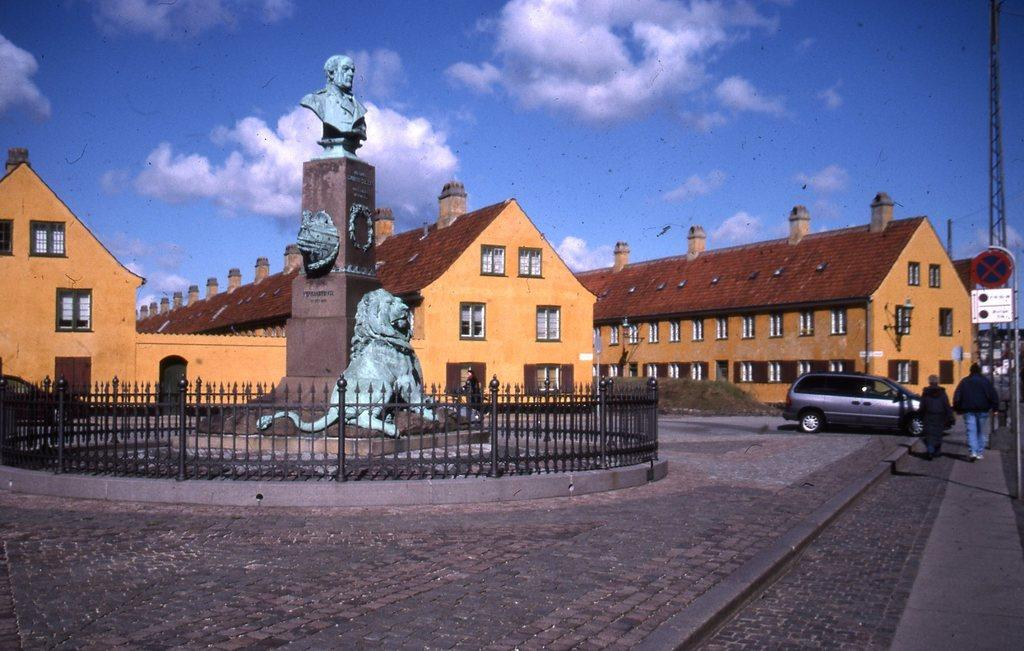What can be seen in the image that represents human-made structures? There are statues, a fence, a car, a sign board, buildings, and a pole in the image. What type of transportation is visible in the image? There is a car on the road in the image. What are the two persons in the image doing? Two persons are walking on the road in the image. What is the condition of the sky in the image? The sky is visible in the image, and clouds are present in the sky. How many tickets are visible on the pole in the image? There are no tickets present on the pole in the image. What type of truck can be seen driving on the road in the image? There is no truck visible on the road in the image; only a car is present. 